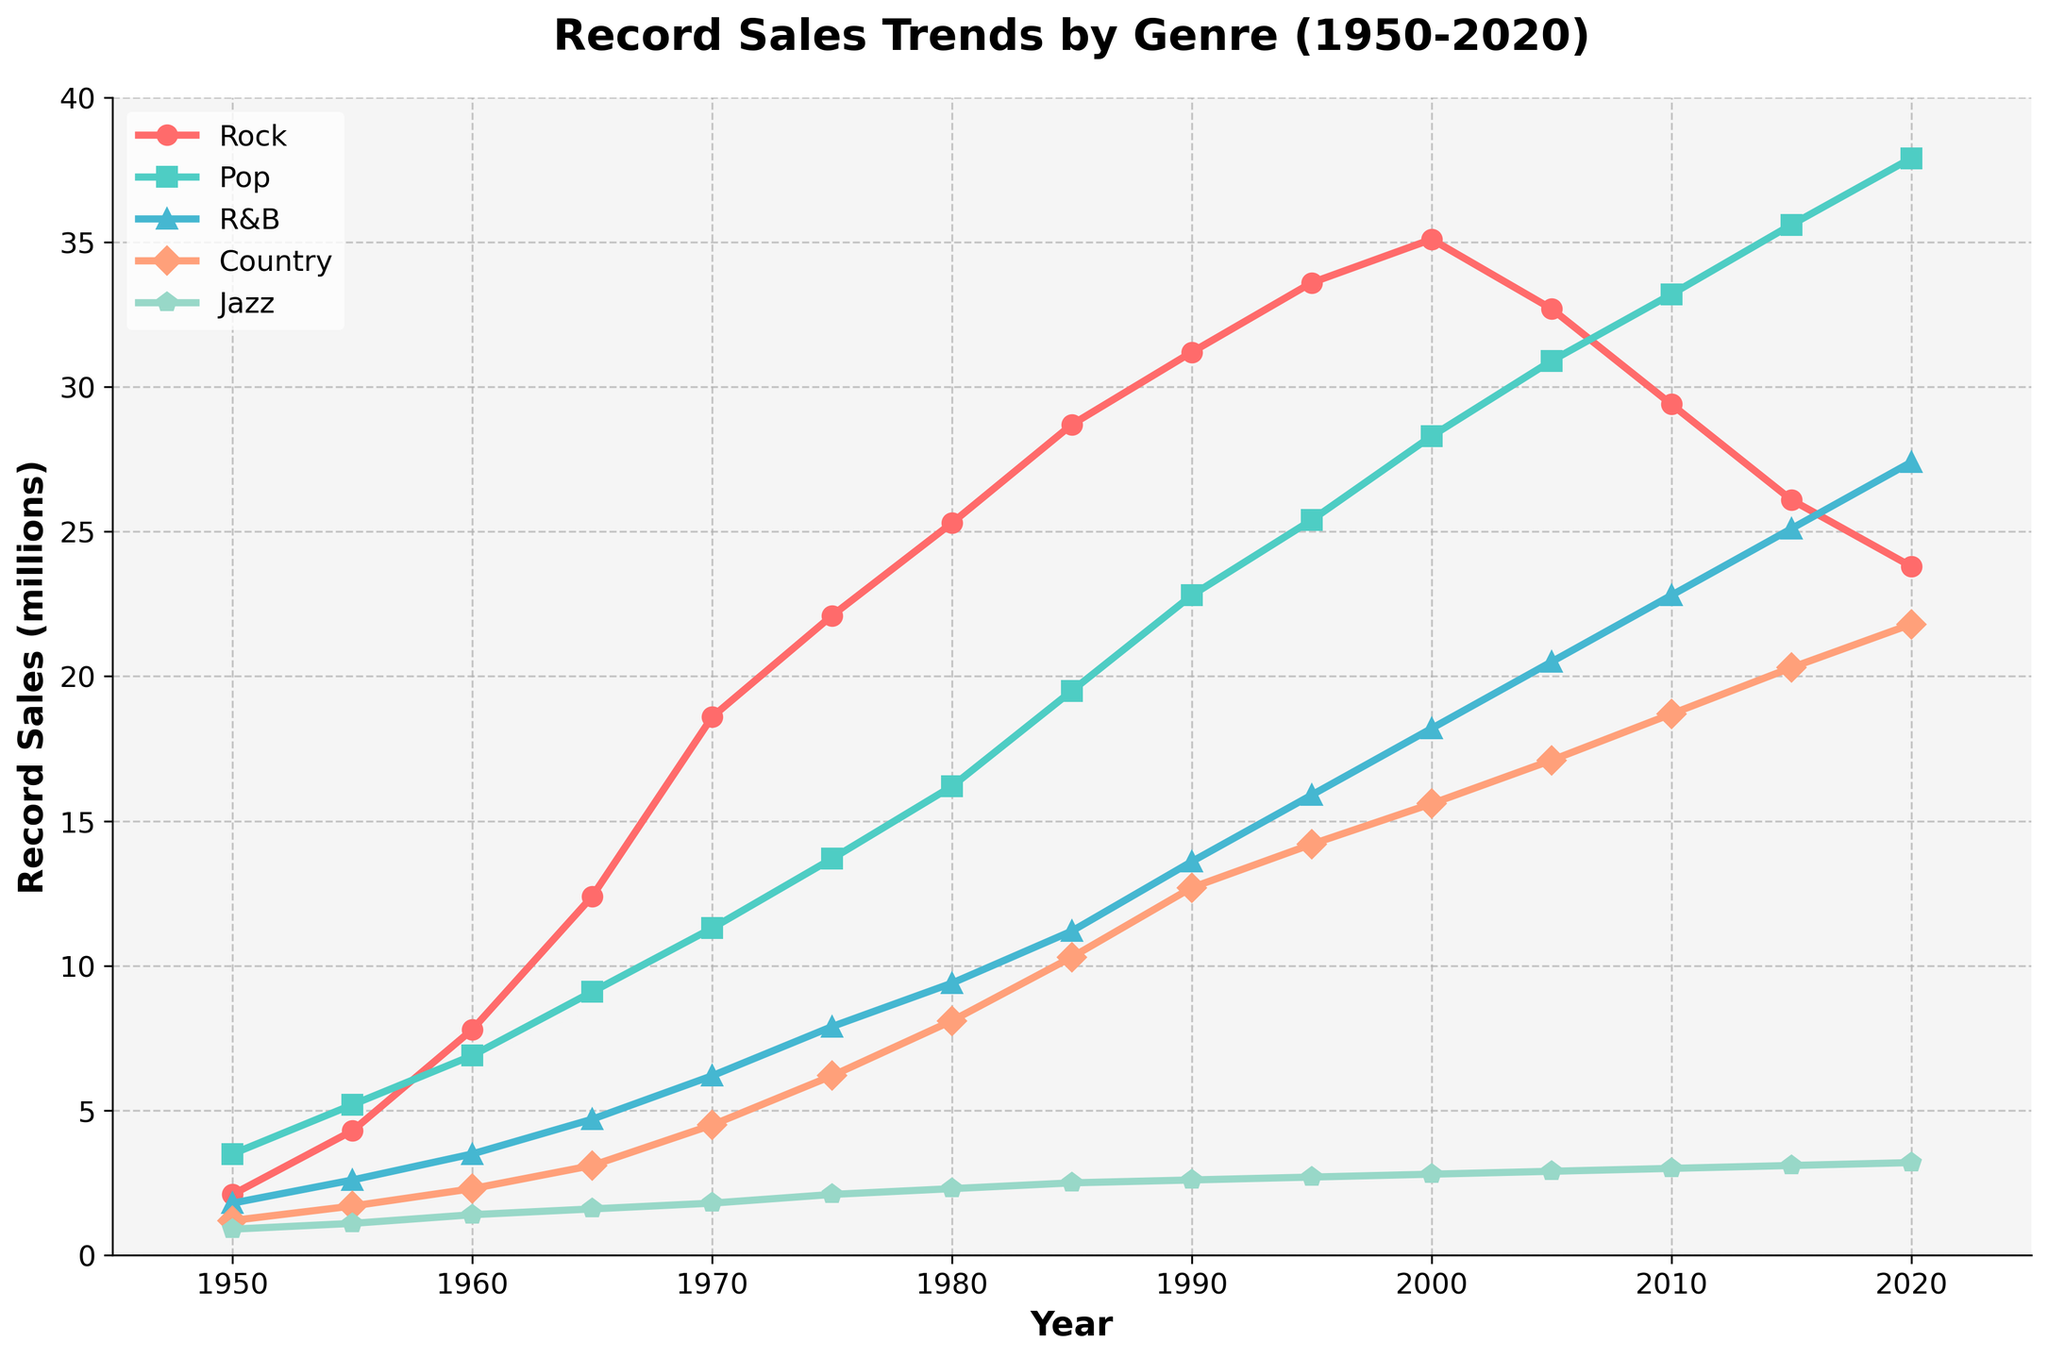What's the trend of Rock sales from 1950 to 2020? By looking at the line representing Rock, it's evident that sales generally increased over the years, peaking around 2000, and then started to decline slightly after 2000.
Answer: Increasing till 2000, then decreasing In which year did Pop surpass Rock in sales? Comparing the lines for Pop and Rock, we see Pop surpasses Rock in 2005, where the Pop line crosses above the Rock line.
Answer: 2005 What was the difference in R&B sales between 1960 and 1985? The sales for R&B in 1960 were 3.5 million and in 1985 were 11.2 million. Subtracting these values gives us 11.2 - 3.5 = 7.7 million.
Answer: 7.7 million When did Jazz sales appear to stagnate the most, based on the line pattern? The line for Jazz sales seems relatively flat between 1950 and 2020, indicating a consistent but low sales level with minimal peaks or declines.
Answer: Entire period (1950-2020) How does the trend of Country music sales compare to Jazz from 1950 to 2020? Country music sales show a steady increase over the years, while Jazz sales remain fairly flat and consistently low.
Answer: Increasing vs. flat Which genre had the highest sales in 2015? By examining the lines in 2015, Pop has the highest point among all genres.
Answer: Pop Did R&B sales ever exceed those of Rock? By looking at the R&B and Rock sales lines, R&B never exceeds Rock at any point from 1950 to 2020.
Answer: No What visual element helps clarify that Rock sales peaked around 2000? The peak of the line for Rock around 2000 is noticeable by the highest point or 'spike' on the graph, which then trends downward.
Answer: Highest point/peak 